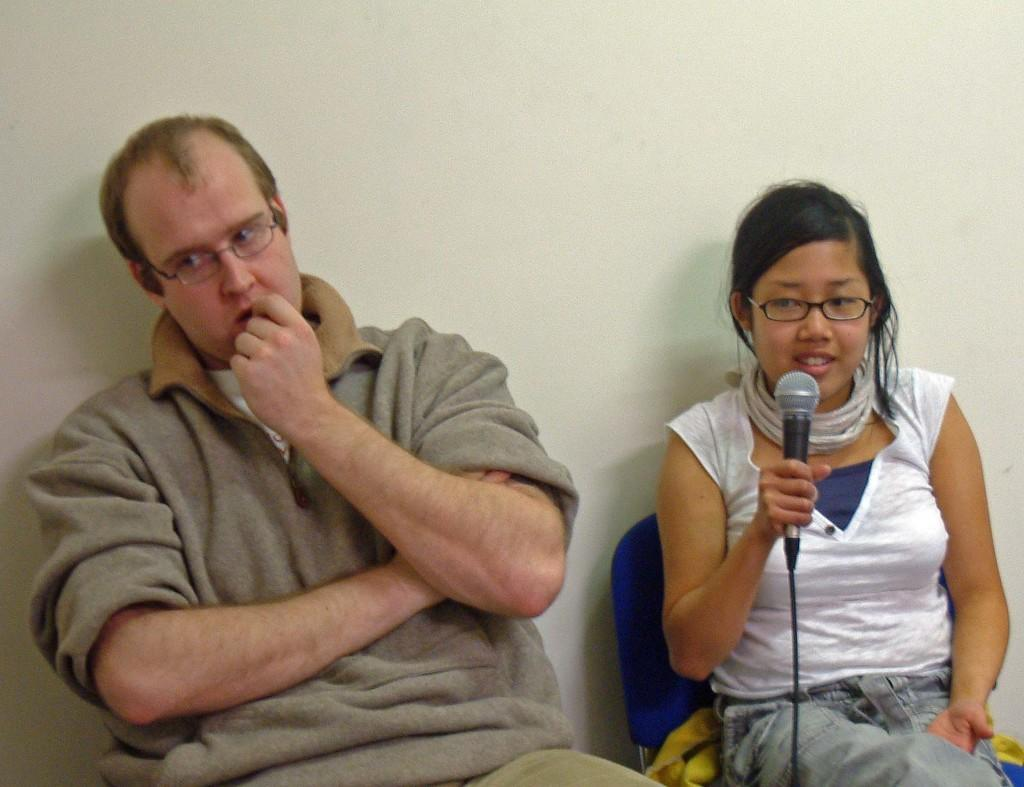Where is the image taken? The image is captured inside a room. Can you describe the man in the image? The man in the image is wearing a sweater. What is the woman in the image doing? The woman is speaking from a mic. What can be seen in the background of the image? There is a wall visible in the background of the image. What color is the man's tongue in the image? There is no information about the man's tongue in the image, as it is not visible. 